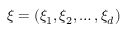Convert formula to latex. <formula><loc_0><loc_0><loc_500><loc_500>{ \xi } = ( \xi _ { 1 } , \xi _ { 2 } , \dots , \xi _ { d } )</formula> 